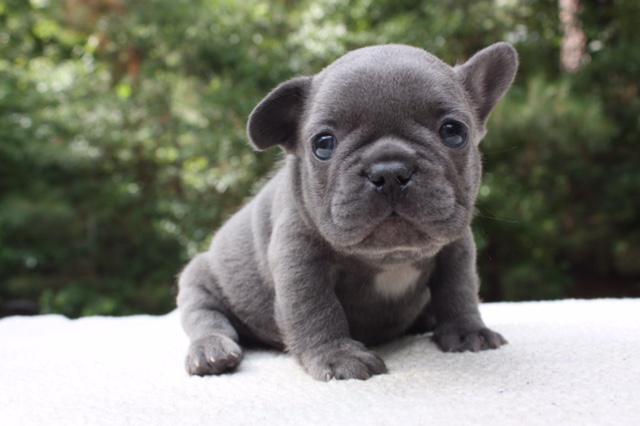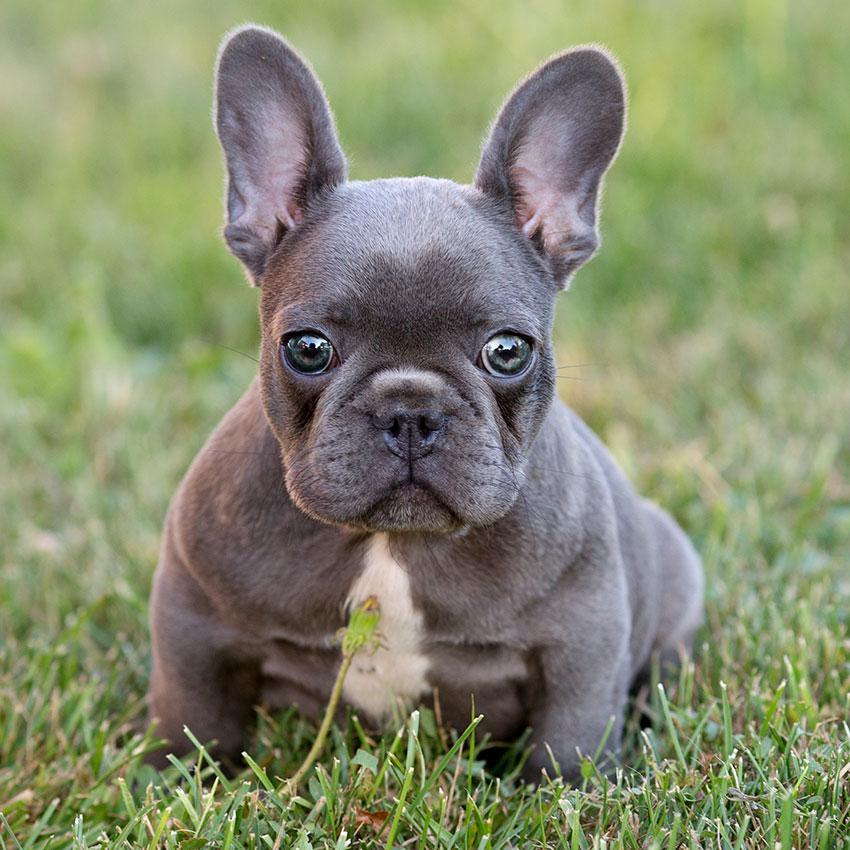The first image is the image on the left, the second image is the image on the right. Given the left and right images, does the statement "There are at most two dogs." hold true? Answer yes or no. Yes. The first image is the image on the left, the second image is the image on the right. Given the left and right images, does the statement "The image on the left contains no more than one dog with its ears perked up." hold true? Answer yes or no. No. 